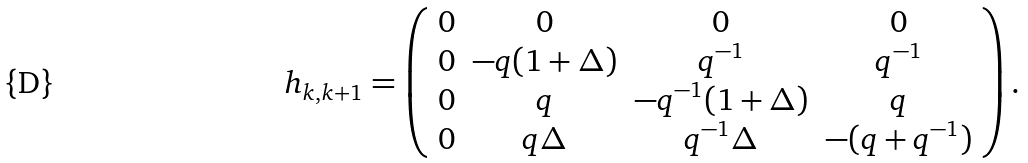<formula> <loc_0><loc_0><loc_500><loc_500>h _ { k , k + 1 } = \left ( \begin{array} { c c c c } 0 & 0 & 0 & 0 \\ 0 & - q ( 1 + \Delta ) & q ^ { - 1 } & q ^ { - 1 } \\ 0 & q & - q ^ { - 1 } ( 1 + \Delta ) & q \\ 0 & q \Delta & q ^ { - 1 } \Delta & - ( q + q ^ { - 1 } ) \\ \end{array} \right ) .</formula> 